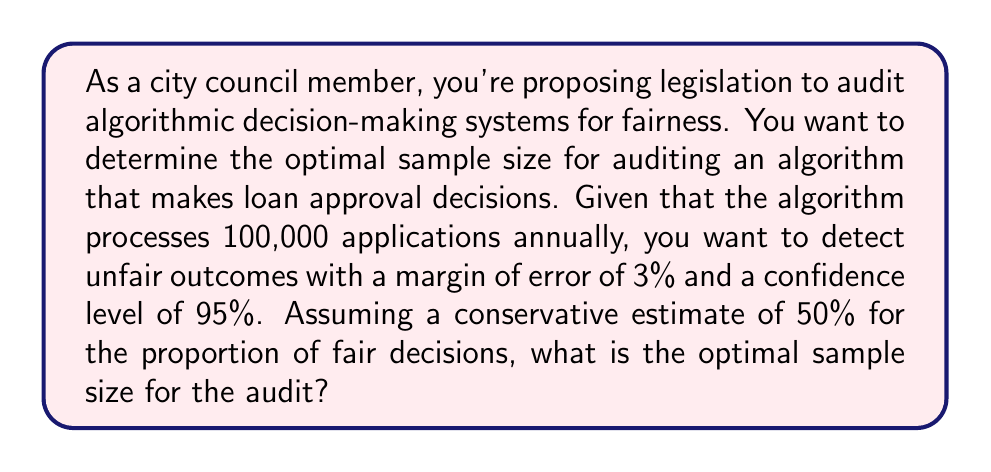Provide a solution to this math problem. To determine the optimal sample size for auditing algorithm fairness, we can use the formula for sample size calculation in a finite population:

$$n = \frac{N \cdot z^2 \cdot p(1-p)}{(N-1) \cdot e^2 + z^2 \cdot p(1-p)}$$

Where:
$n$ = sample size
$N$ = population size (100,000 applications)
$z$ = z-score (1.96 for 95% confidence level)
$p$ = estimated proportion (0.5 for conservative estimate)
$e$ = margin of error (0.03 or 3%)

Step 1: Substitute the values into the formula:

$$n = \frac{100000 \cdot 1.96^2 \cdot 0.5(1-0.5)}{(100000-1) \cdot 0.03^2 + 1.96^2 \cdot 0.5(1-0.5)}$$

Step 2: Calculate the numerator:
$100000 \cdot 1.96^2 \cdot 0.5(1-0.5) = 96040$

Step 3: Calculate the denominator:
$(100000-1) \cdot 0.03^2 + 1.96^2 \cdot 0.5(1-0.5) = 89.9904 + 0.9604 = 90.9508$

Step 4: Divide the numerator by the denominator:
$$n = \frac{96040}{90.9508} = 1055.95$$

Step 5: Round up to the nearest whole number, as we can't have a fractional sample size.

Therefore, the optimal sample size for the audit is 1056 applications.
Answer: 1056 applications 